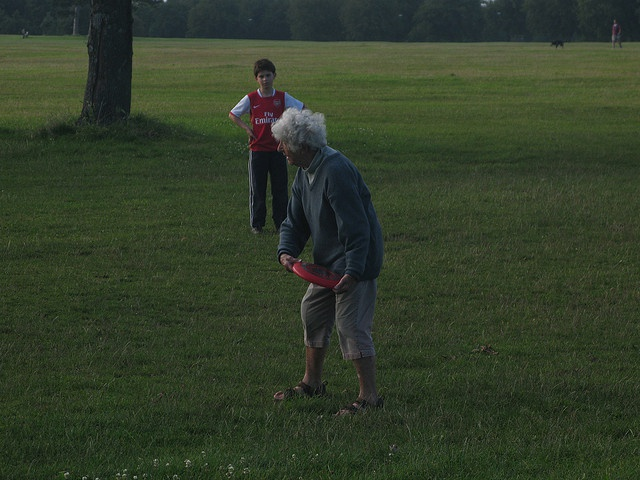Describe the objects in this image and their specific colors. I can see people in black, gray, and darkblue tones, people in black, maroon, gray, and darkgreen tones, and frisbee in black, maroon, and brown tones in this image. 